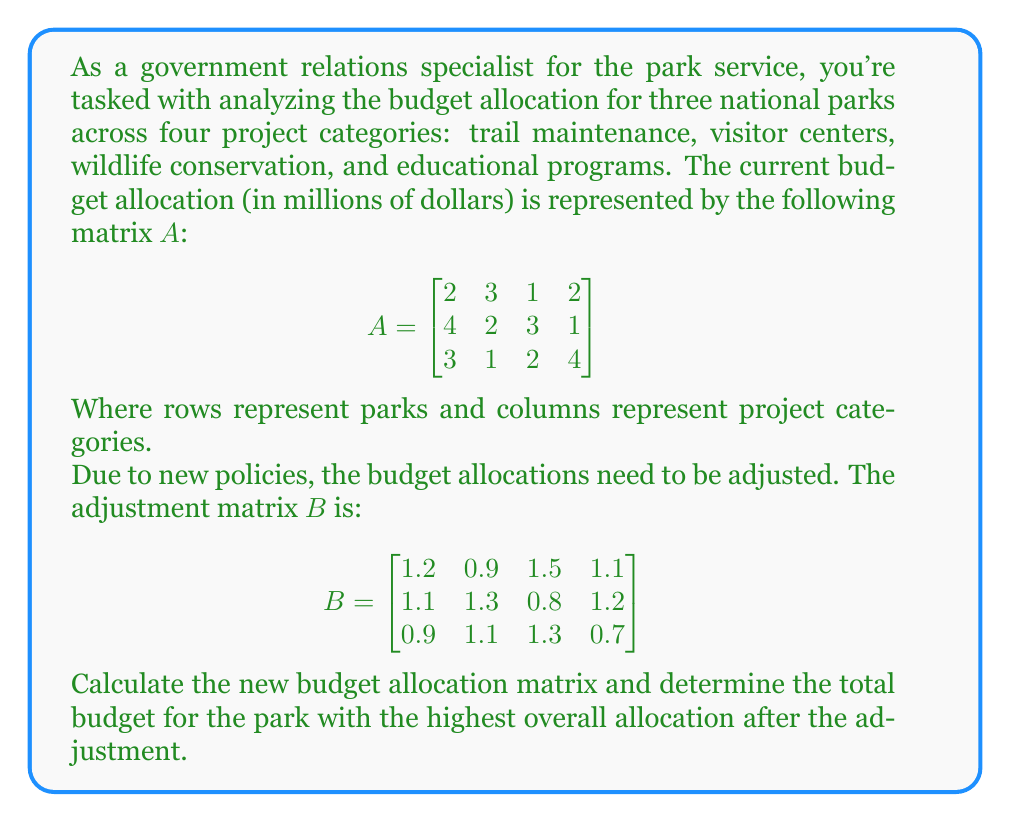Help me with this question. To solve this problem, we need to follow these steps:

1) First, we need to calculate the new budget allocation matrix. This is done by multiplying each element in matrix $A$ by the corresponding element in matrix $B$. This operation is called the Hadamard product (or element-wise multiplication) and is denoted by $\circ$. 

   Let's call the new budget allocation matrix $C$:

   $$C = A \circ B$$

2) Let's perform the element-wise multiplication:

   $$C = \begin{bmatrix}
   2(1.2) & 3(0.9) & 1(1.5) & 2(1.1) \\
   4(1.1) & 2(1.3) & 3(0.8) & 1(1.2) \\
   3(0.9) & 1(1.1) & 2(1.3) & 4(0.7)
   \end{bmatrix}$$

   $$C = \begin{bmatrix}
   2.4 & 2.7 & 1.5 & 2.2 \\
   4.4 & 2.6 & 2.4 & 1.2 \\
   2.7 & 1.1 & 2.6 & 2.8
   \end{bmatrix}$$

3) Now that we have the new budget allocation matrix, we need to find the total budget for each park. We can do this by summing the elements in each row of matrix $C$:

   Park 1: $2.4 + 2.7 + 1.5 + 2.2 = 8.8$ million
   Park 2: $4.4 + 2.6 + 2.4 + 1.2 = 10.6$ million
   Park 3: $2.7 + 1.1 + 2.6 + 2.8 = 9.2$ million

4) The park with the highest overall allocation after the adjustment is Park 2 with a total budget of $10.6 million.
Answer: The park with the highest overall allocation after the adjustment is Park 2 with a total budget of $10.6 million. 